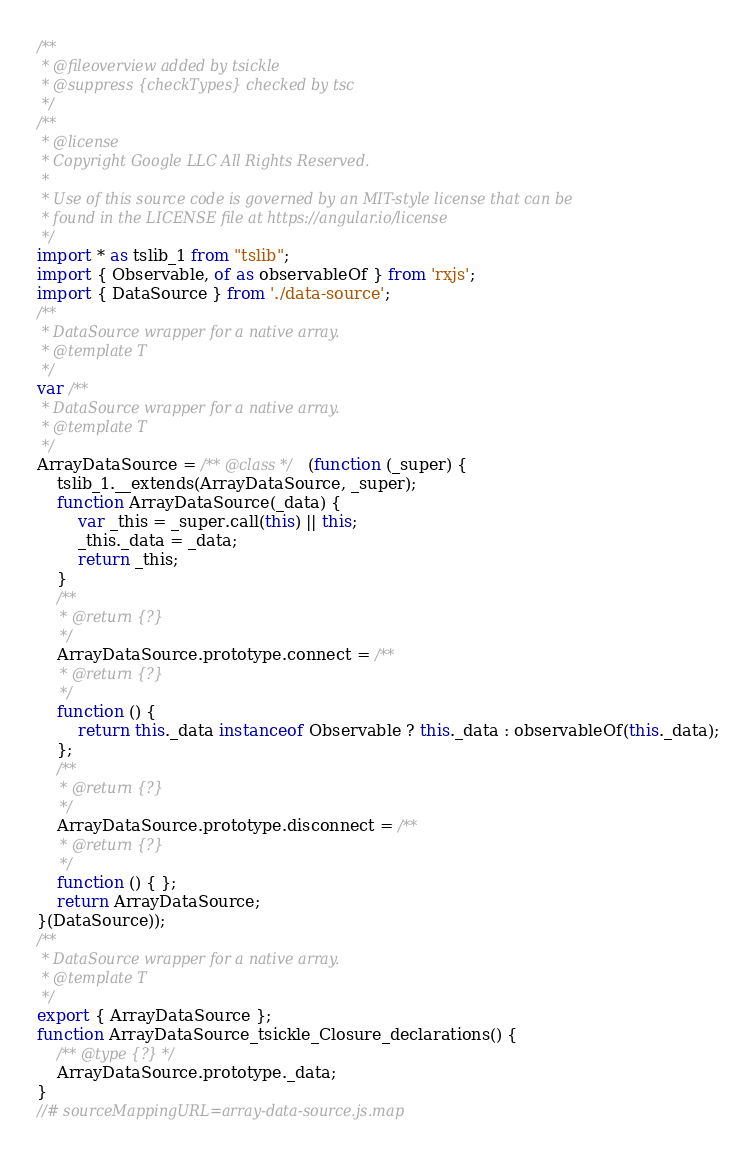<code> <loc_0><loc_0><loc_500><loc_500><_JavaScript_>/**
 * @fileoverview added by tsickle
 * @suppress {checkTypes} checked by tsc
 */
/**
 * @license
 * Copyright Google LLC All Rights Reserved.
 *
 * Use of this source code is governed by an MIT-style license that can be
 * found in the LICENSE file at https://angular.io/license
 */
import * as tslib_1 from "tslib";
import { Observable, of as observableOf } from 'rxjs';
import { DataSource } from './data-source';
/**
 * DataSource wrapper for a native array.
 * @template T
 */
var /**
 * DataSource wrapper for a native array.
 * @template T
 */
ArrayDataSource = /** @class */ (function (_super) {
    tslib_1.__extends(ArrayDataSource, _super);
    function ArrayDataSource(_data) {
        var _this = _super.call(this) || this;
        _this._data = _data;
        return _this;
    }
    /**
     * @return {?}
     */
    ArrayDataSource.prototype.connect = /**
     * @return {?}
     */
    function () {
        return this._data instanceof Observable ? this._data : observableOf(this._data);
    };
    /**
     * @return {?}
     */
    ArrayDataSource.prototype.disconnect = /**
     * @return {?}
     */
    function () { };
    return ArrayDataSource;
}(DataSource));
/**
 * DataSource wrapper for a native array.
 * @template T
 */
export { ArrayDataSource };
function ArrayDataSource_tsickle_Closure_declarations() {
    /** @type {?} */
    ArrayDataSource.prototype._data;
}
//# sourceMappingURL=array-data-source.js.map</code> 